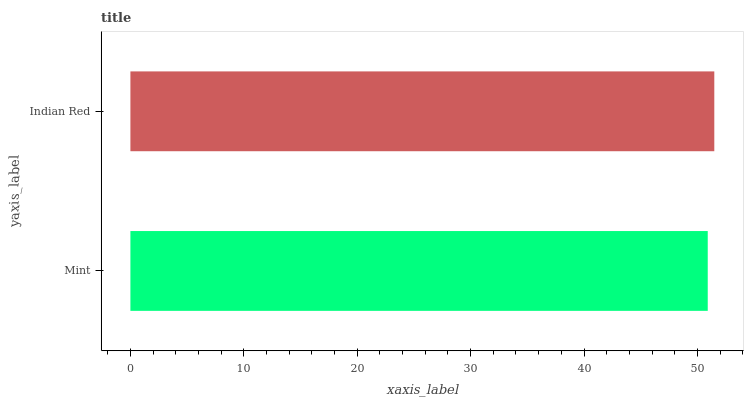Is Mint the minimum?
Answer yes or no. Yes. Is Indian Red the maximum?
Answer yes or no. Yes. Is Indian Red the minimum?
Answer yes or no. No. Is Indian Red greater than Mint?
Answer yes or no. Yes. Is Mint less than Indian Red?
Answer yes or no. Yes. Is Mint greater than Indian Red?
Answer yes or no. No. Is Indian Red less than Mint?
Answer yes or no. No. Is Indian Red the high median?
Answer yes or no. Yes. Is Mint the low median?
Answer yes or no. Yes. Is Mint the high median?
Answer yes or no. No. Is Indian Red the low median?
Answer yes or no. No. 